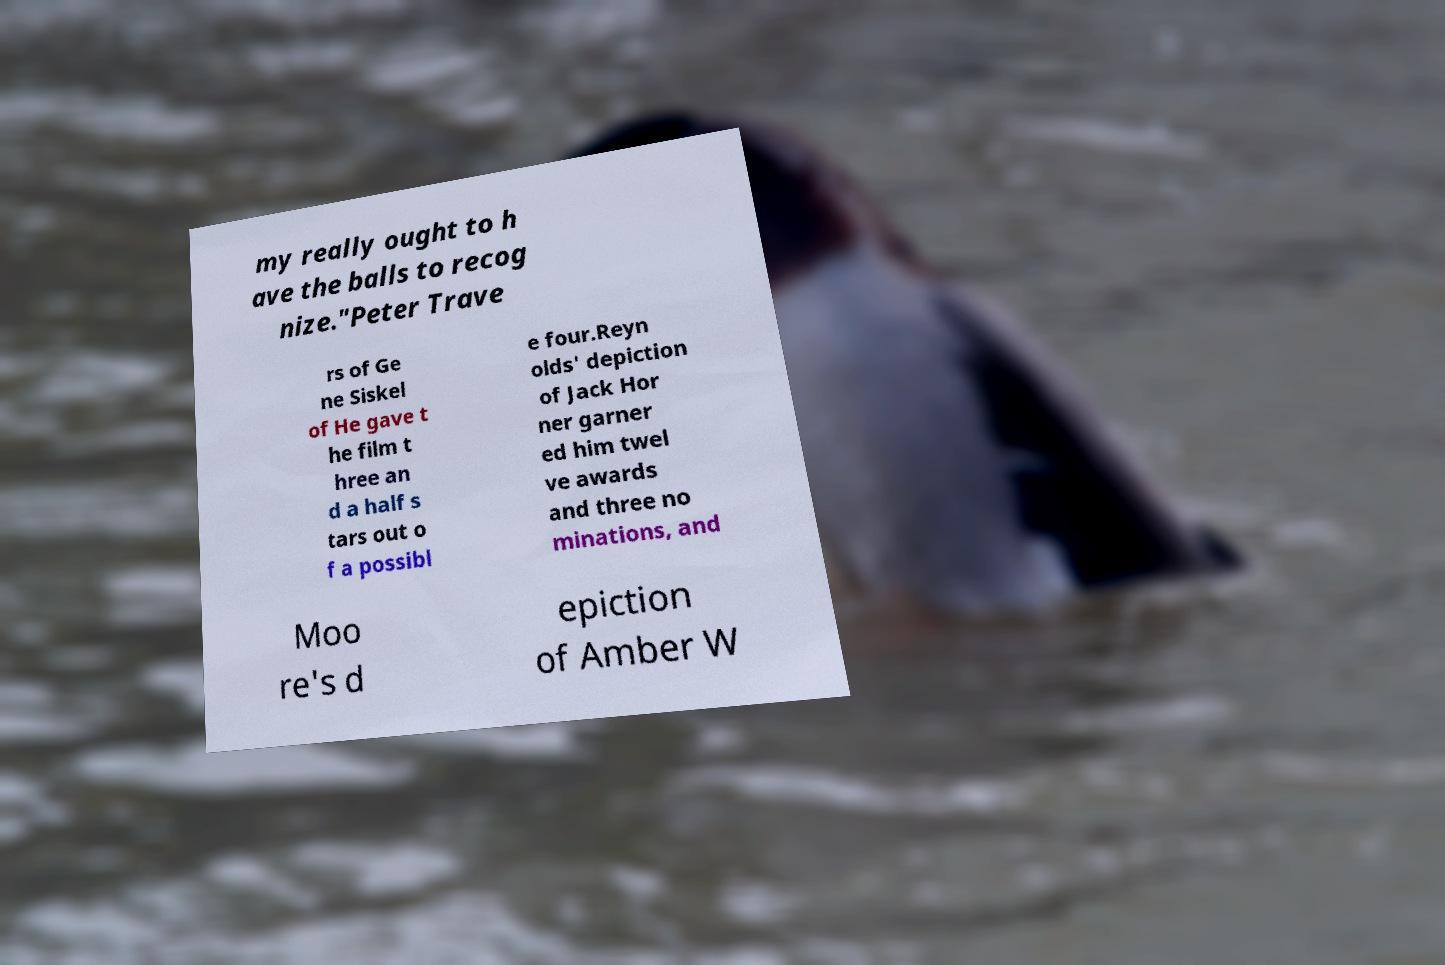Could you extract and type out the text from this image? my really ought to h ave the balls to recog nize."Peter Trave rs of Ge ne Siskel of He gave t he film t hree an d a half s tars out o f a possibl e four.Reyn olds' depiction of Jack Hor ner garner ed him twel ve awards and three no minations, and Moo re's d epiction of Amber W 